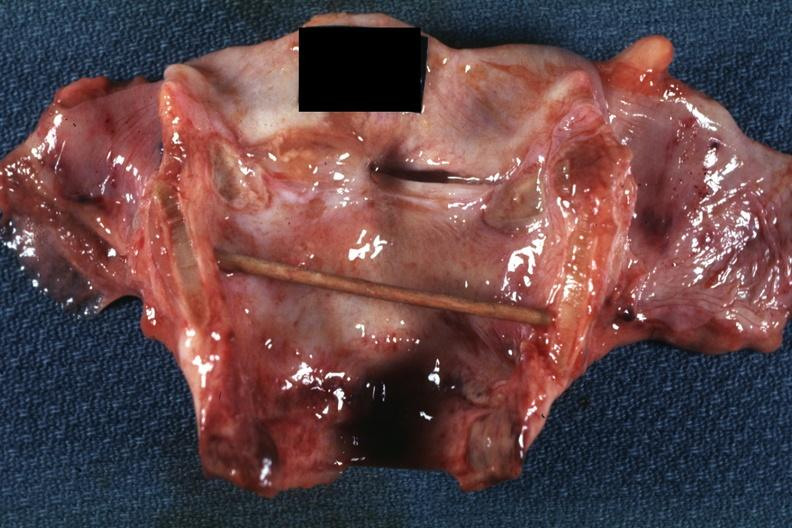what is present?
Answer the question using a single word or phrase. Larynx 